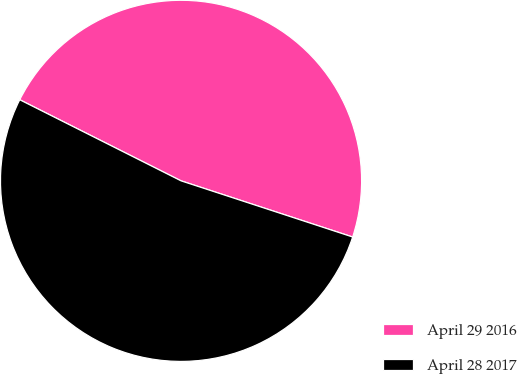<chart> <loc_0><loc_0><loc_500><loc_500><pie_chart><fcel>April 29 2016<fcel>April 28 2017<nl><fcel>47.62%<fcel>52.38%<nl></chart> 